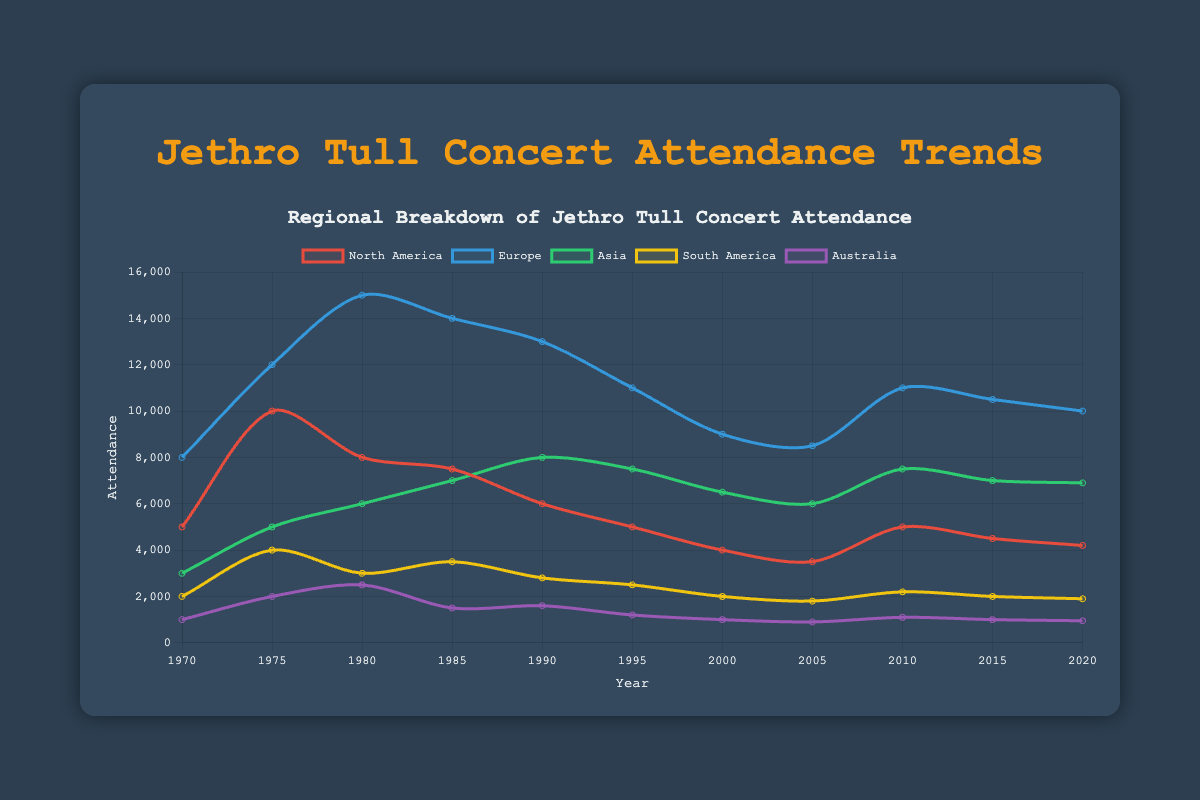What was the attendance in North America in 1975? Look for the year 1975 on the x-axis, then refer to the North America line (red). The data point indicates an attendance of 10,000.
Answer: 10,000 How did the attendance in Europe change from 1970 to 1980? First locate the data point for Europe (blue) in 1970, which is 8,000. Then look for the data point in 1980, which is 15,000. The difference is 15,000 - 8,000 = 7,000, indicating an increase.
Answer: Increase by 7,000 Which region had the highest attendance in 1990? Locate the year 1990 on the x-axis and check all lines. Europe (blue) shows the highest value which is 13,000.
Answer: Europe What is the average attendance for Asia across the reported years? Sum the attendance values for Asia (green line) across all years (3000 + 5000 + 6000 + 7000 + 8000 + 7500 + 6500 + 6000 + 7500 + 7000 + 6900 = 70900) and then divide by the number of data points (11). 70900 / 11 = 6445.45.
Answer: Approximately 6,445 Which two regions had the closest attendance figures in 2020? For 2020, look at the end of all lines. North America (4,200) and Asia (6,900) have a smaller difference (2,700) compared to others.
Answer: North America and Asia Between which two consecutive years did the greatest decline in attendance occur for North America? Look at the red line and compare the drop between each year. The largest drop is between 1975 and 1980 (10,000 to 8,000), a decline of 2,000.
Answer: 1975 to 1980 In which year did South America have the highest concert attendance? Trace the yellow line for the highest point. 1985 shows the peak at 3,500.
Answer: 1985 What is the trend in Australia’s attendance from 2000 to 2005? Look at the purple line from 2000 (1,000) to 2005 (900). The attendance decreased by 100.
Answer: Decreasing How many times did Europe’s attendance surpass 10,000? Locate the blue line and count the data points above 10,000. These occur in 1975, 1980, 1985, 1990, 2010.
Answer: 5 times Which year had the smallest difference between the highest and lowest regional attendances? Identify the differences between the highest and lowest points for each year. 1985: Highest (Europe 14,000) - Lowest (Australia 1,500) = 12,500. Other years show larger differences.
Answer: 1985 